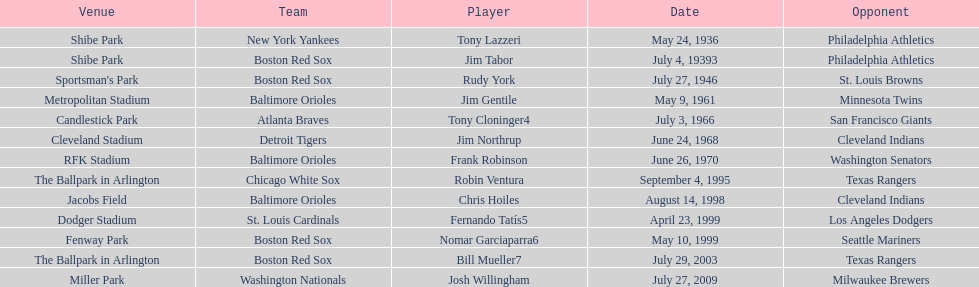What is the number of times a boston red sox player has had two grand slams in one game? 4. 